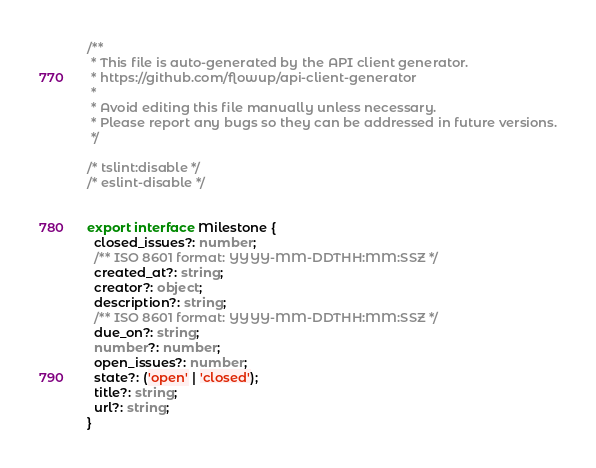<code> <loc_0><loc_0><loc_500><loc_500><_TypeScript_>/**
 * This file is auto-generated by the API client generator.
 * https://github.com/flowup/api-client-generator
 *
 * Avoid editing this file manually unless necessary.
 * Please report any bugs so they can be addressed in future versions.
 */

/* tslint:disable */
/* eslint-disable */


export interface Milestone {
  closed_issues?: number;
  /** ISO 8601 format: YYYY-MM-DDTHH:MM:SSZ */
  created_at?: string;
  creator?: object;
  description?: string;
  /** ISO 8601 format: YYYY-MM-DDTHH:MM:SSZ */
  due_on?: string;
  number?: number;
  open_issues?: number;
  state?: ('open' | 'closed');
  title?: string;
  url?: string;
}
</code> 